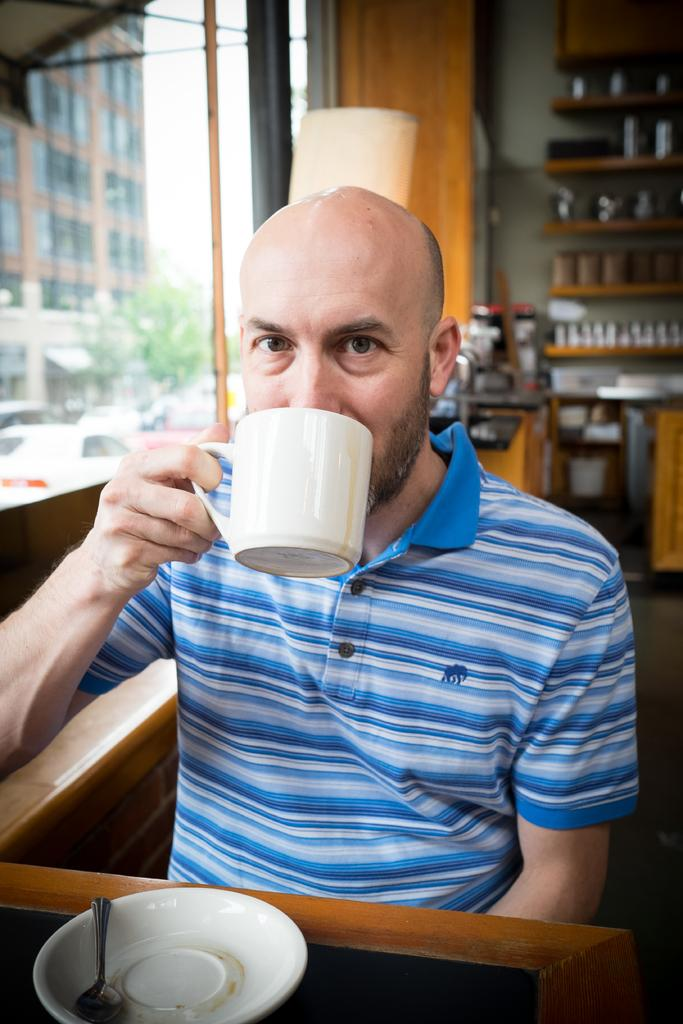What is the person in the image holding? He is holding a cup. What is on the table in the image? There is a saucer and a spoon on the table. What can be seen in the background of the image? In the background, there is a building, a tree, and a cupboard. What type of pear is the queen holding in the image? There is no queen or pear present in the image. Is the bear sitting on the table in the image? There is no bear present in the image. 